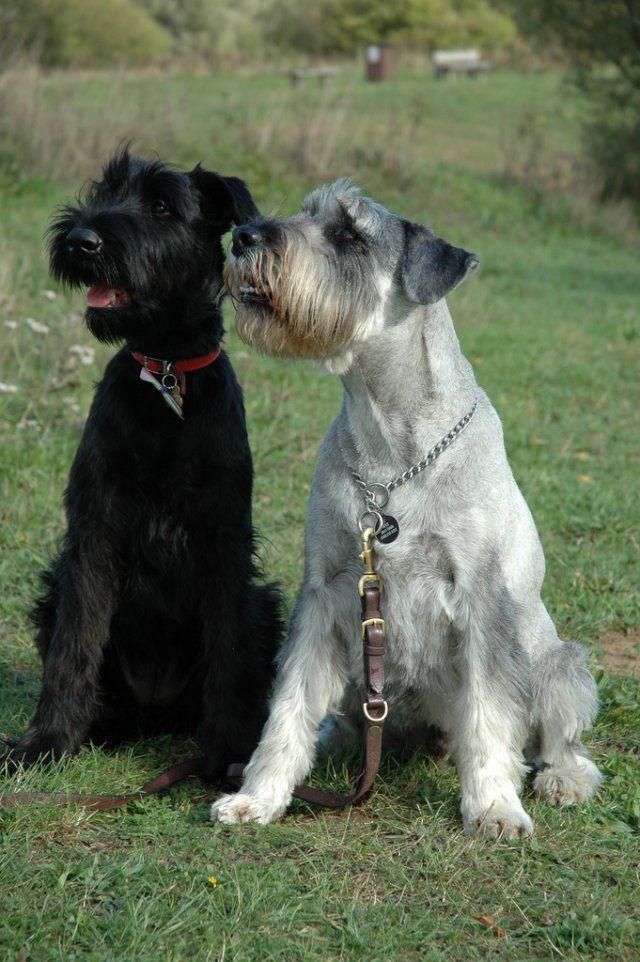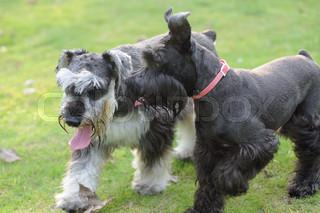The first image is the image on the left, the second image is the image on the right. Assess this claim about the two images: "a dog is standing in the grass with a taught leash". Correct or not? Answer yes or no. No. 